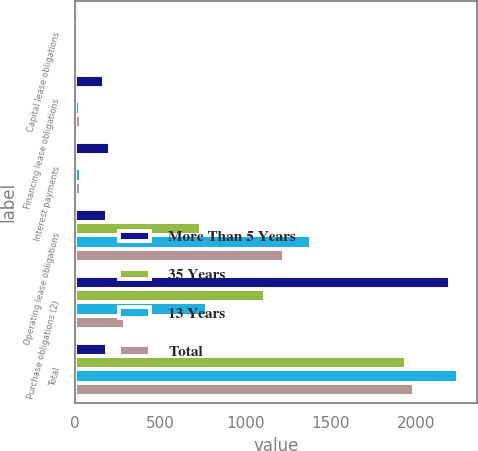<chart> <loc_0><loc_0><loc_500><loc_500><stacked_bar_chart><ecel><fcel>Capital lease obligations<fcel>Financing lease obligations<fcel>Interest payments<fcel>Operating lease obligations<fcel>Purchase obligations (2)<fcel>Total<nl><fcel>More Than 5 Years<fcel>24<fcel>171<fcel>208<fcel>189.5<fcel>2198<fcel>189.5<nl><fcel>35 Years<fcel>3<fcel>14<fcel>25<fcel>741<fcel>1113<fcel>1939<nl><fcel>13 Years<fcel>6<fcel>30<fcel>38<fcel>1387<fcel>775<fcel>2245<nl><fcel>Total<fcel>2<fcel>33<fcel>33<fcel>1224<fcel>291<fcel>1986<nl></chart> 